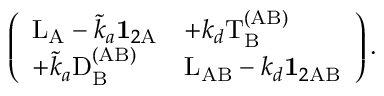Convert formula to latex. <formula><loc_0><loc_0><loc_500><loc_500>\left ( \begin{array} { l l } { L _ { A } - \tilde { k } _ { a } 1 _ { 2 \mathrm A } } & { + k _ { d } T _ { \mathrm B } ^ { ( A B ) } } \\ { + \tilde { k } _ { a } D _ { \mathrm B } ^ { ( A B ) } } & { L _ { A B } - k _ { d } 1 _ { 2 A B } } \end{array} \right ) .</formula> 